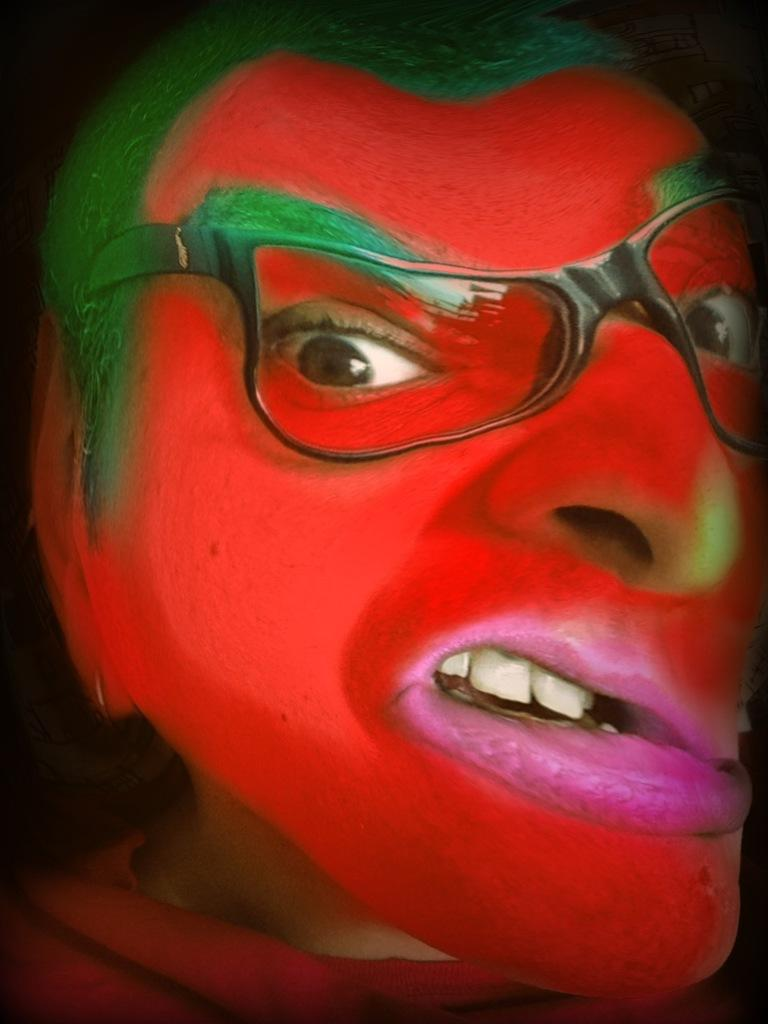What is the main subject of the image? There is a human face in the center of the image. What can be seen on the person's face? The person is wearing glasses and there is colorful paint on their face. What type of letter is being written on the person's face in the image? There is no letter being written on the person's face in the image; it only shows colorful paint. 